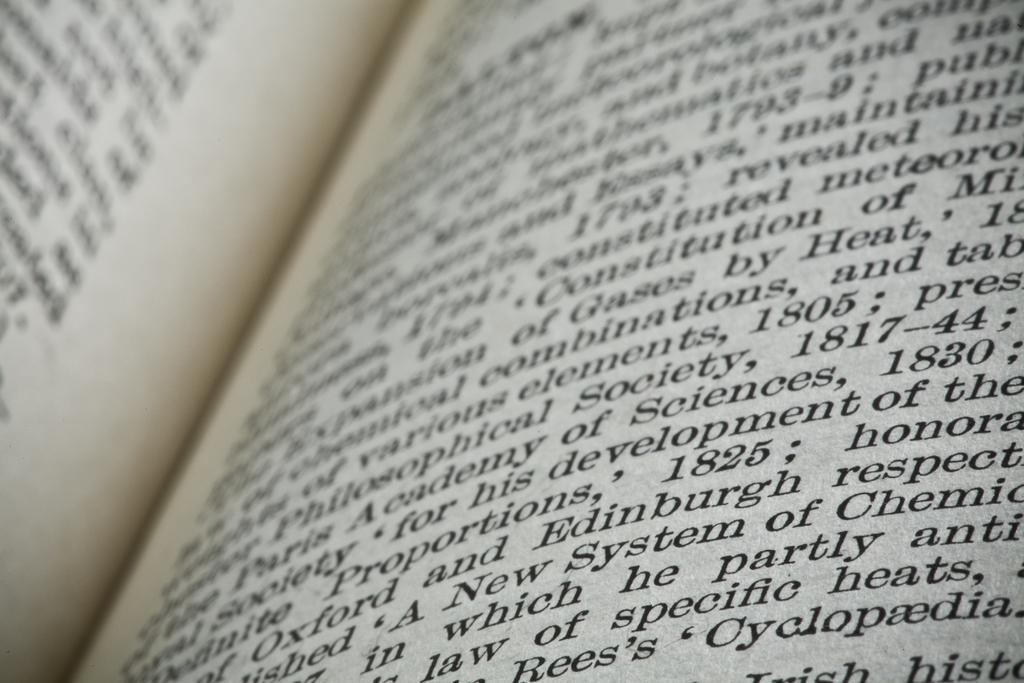<image>
Describe the image concisely. A book that is open which discusses philosophical society. 